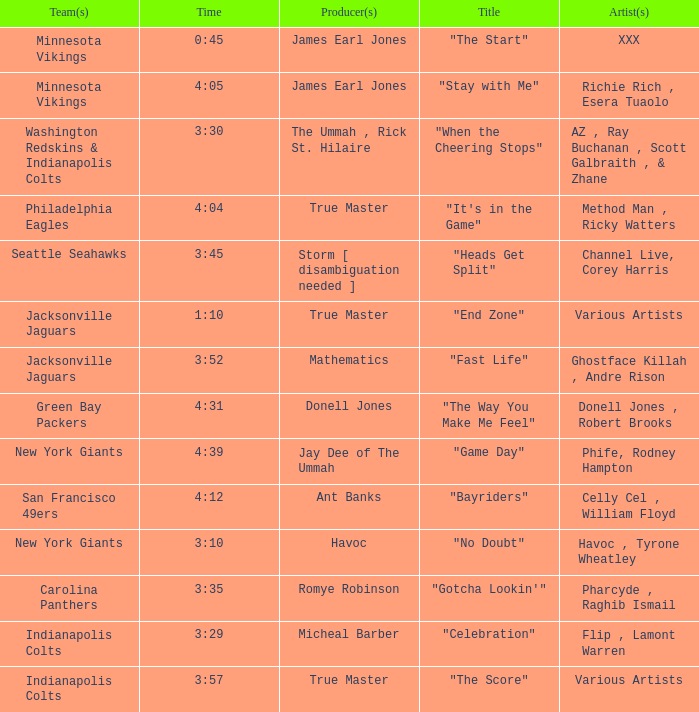Who created the production for "fast life"? Mathematics. Could you parse the entire table as a dict? {'header': ['Team(s)', 'Time', 'Producer(s)', 'Title', 'Artist(s)'], 'rows': [['Minnesota Vikings', '0:45', 'James Earl Jones', '"The Start"', 'XXX'], ['Minnesota Vikings', '4:05', 'James Earl Jones', '"Stay with Me"', 'Richie Rich , Esera Tuaolo'], ['Washington Redskins & Indianapolis Colts', '3:30', 'The Ummah , Rick St. Hilaire', '"When the Cheering Stops"', 'AZ , Ray Buchanan , Scott Galbraith , & Zhane'], ['Philadelphia Eagles', '4:04', 'True Master', '"It\'s in the Game"', 'Method Man , Ricky Watters'], ['Seattle Seahawks', '3:45', 'Storm [ disambiguation needed ]', '"Heads Get Split"', 'Channel Live, Corey Harris'], ['Jacksonville Jaguars', '1:10', 'True Master', '"End Zone"', 'Various Artists'], ['Jacksonville Jaguars', '3:52', 'Mathematics', '"Fast Life"', 'Ghostface Killah , Andre Rison'], ['Green Bay Packers', '4:31', 'Donell Jones', '"The Way You Make Me Feel"', 'Donell Jones , Robert Brooks'], ['New York Giants', '4:39', 'Jay Dee of The Ummah', '"Game Day"', 'Phife, Rodney Hampton'], ['San Francisco 49ers', '4:12', 'Ant Banks', '"Bayriders"', 'Celly Cel , William Floyd'], ['New York Giants', '3:10', 'Havoc', '"No Doubt"', 'Havoc , Tyrone Wheatley'], ['Carolina Panthers', '3:35', 'Romye Robinson', '"Gotcha Lookin\'"', 'Pharcyde , Raghib Ismail'], ['Indianapolis Colts', '3:29', 'Micheal Barber', '"Celebration"', 'Flip , Lamont Warren'], ['Indianapolis Colts', '3:57', 'True Master', '"The Score"', 'Various Artists']]} 